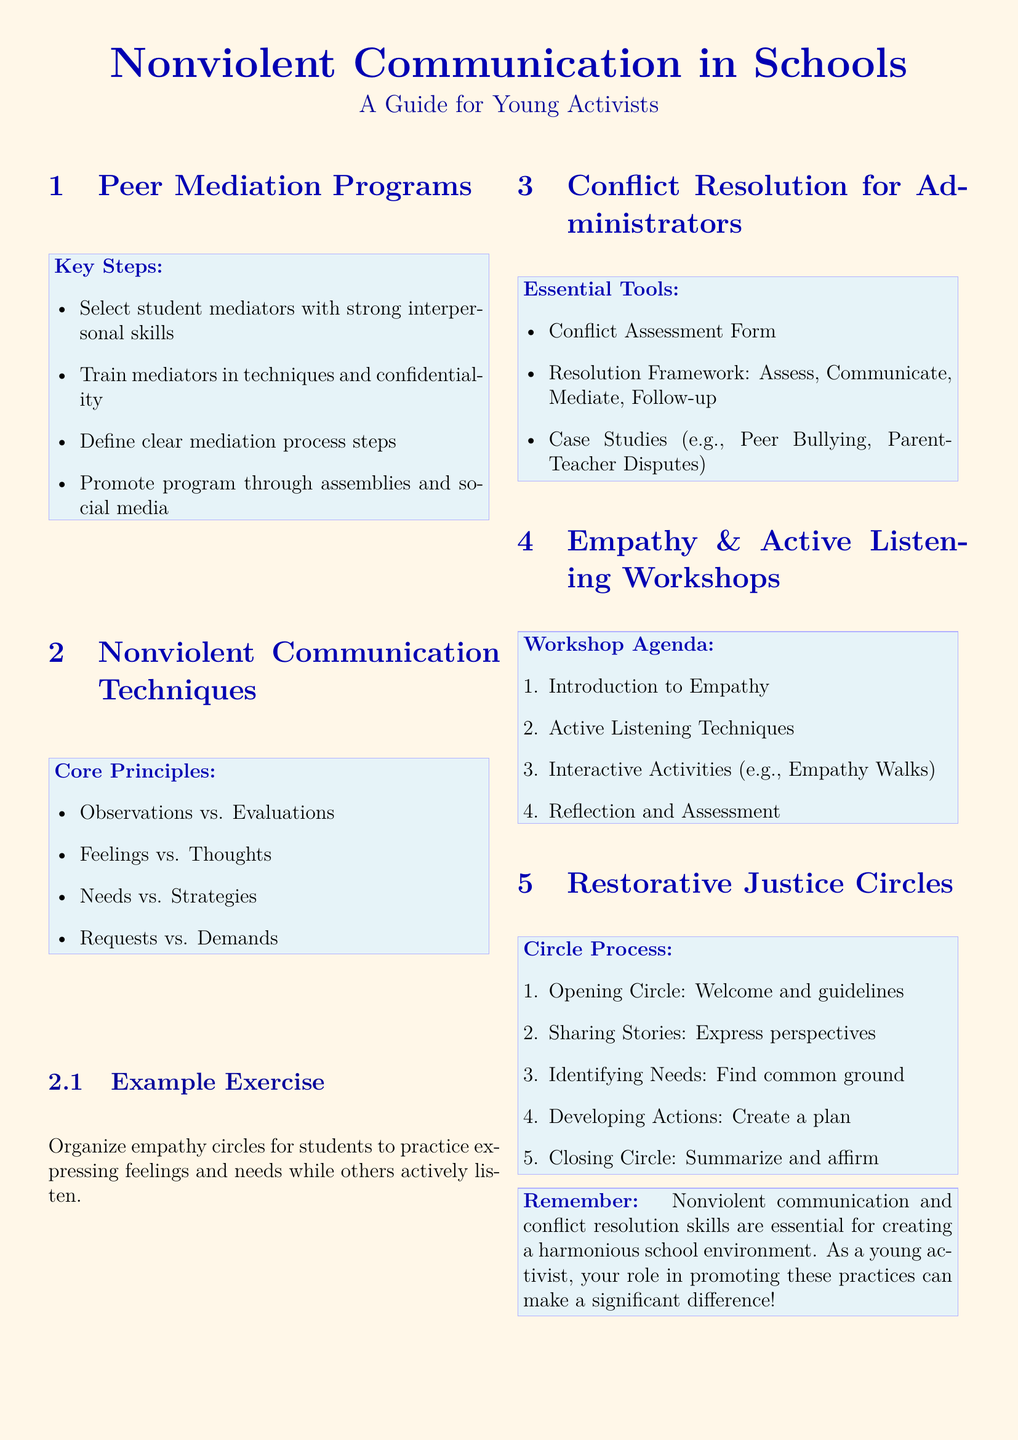what is the title of the document? The title is presented prominently at the start of the document.
Answer: Nonviolent Communication in Schools how many steps are listed for Peer Mediation Programs? The number of steps can be found under the Key Steps section.
Answer: 4 name one core principle of Nonviolent Communication Techniques? The core principles are listed in the relevant section.
Answer: Observations vs. Evaluations what is the first item on the workshop agenda for Empathy & Active Listening? The order of items can be found in the Workshop Agenda section.
Answer: Introduction to Empathy what is the first step in the Circle Process for Restorative Justice Circles? The steps are outlined clearly under the Circle Process section.
Answer: Opening Circle how many essential tools are listed for Conflict Resolution for Administrators? The document provides a specific count of tools in the Essential Tools section.
Answer: 3 what activity is suggested for practicing empathy within Nonviolent Communication? The document mentions specific activities related to practicing communication skills.
Answer: Empathy circles what is the purpose of restorative justice circles as specified in the document? The aim or function is implied within the context of the Circle Process description.
Answer: Address harm and rebuild relationships what framework is used in Conflict Resolution for Administrators? The framework is outlined in the Essential Tools section.
Answer: Assess, Communicate, Mediate, Follow-up 